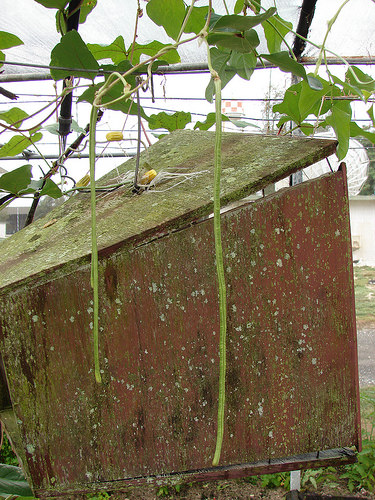<image>
Is there a plant above the box? Yes. The plant is positioned above the box in the vertical space, higher up in the scene. 